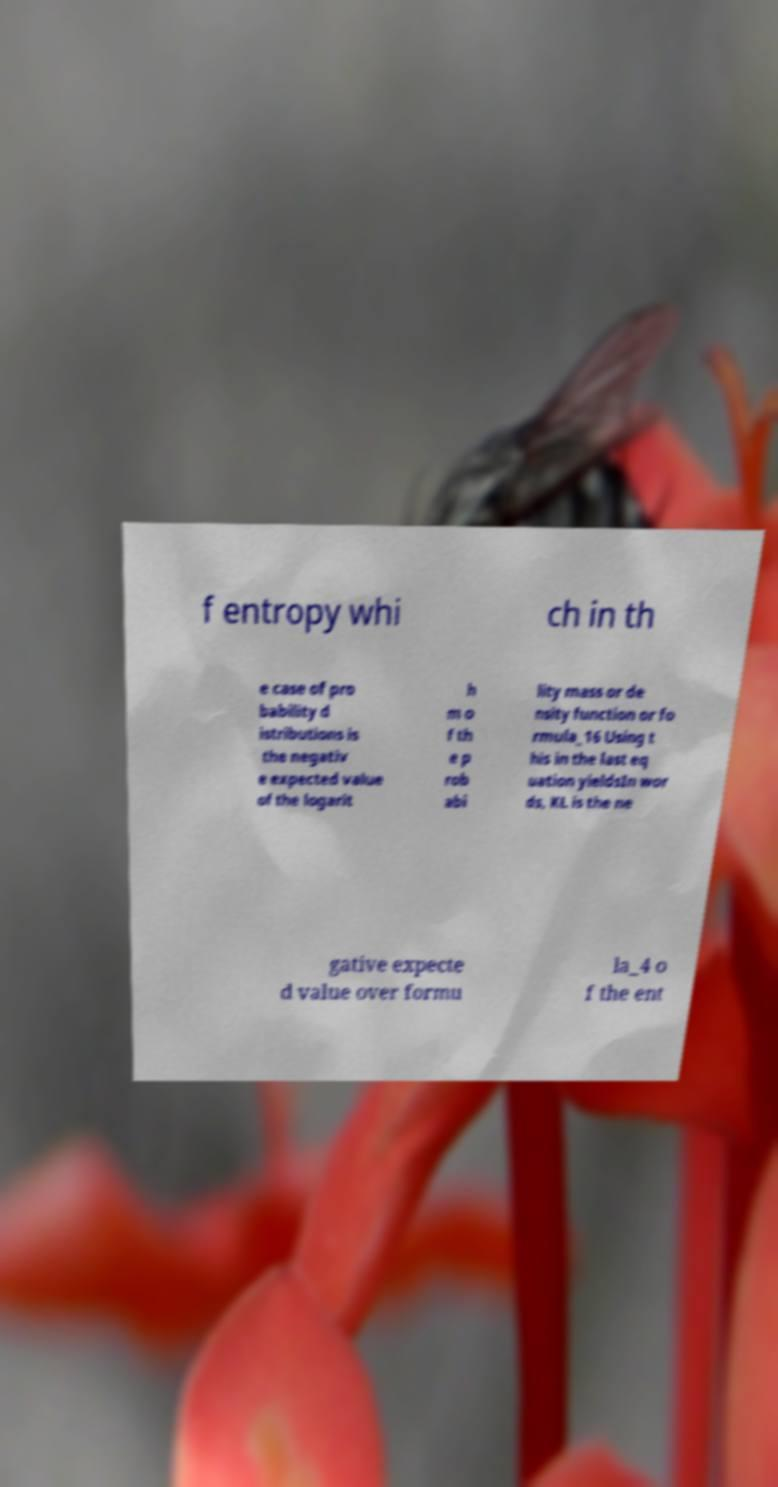Can you accurately transcribe the text from the provided image for me? f entropy whi ch in th e case of pro bability d istributions is the negativ e expected value of the logarit h m o f th e p rob abi lity mass or de nsity function or fo rmula_16 Using t his in the last eq uation yieldsIn wor ds, KL is the ne gative expecte d value over formu la_4 o f the ent 